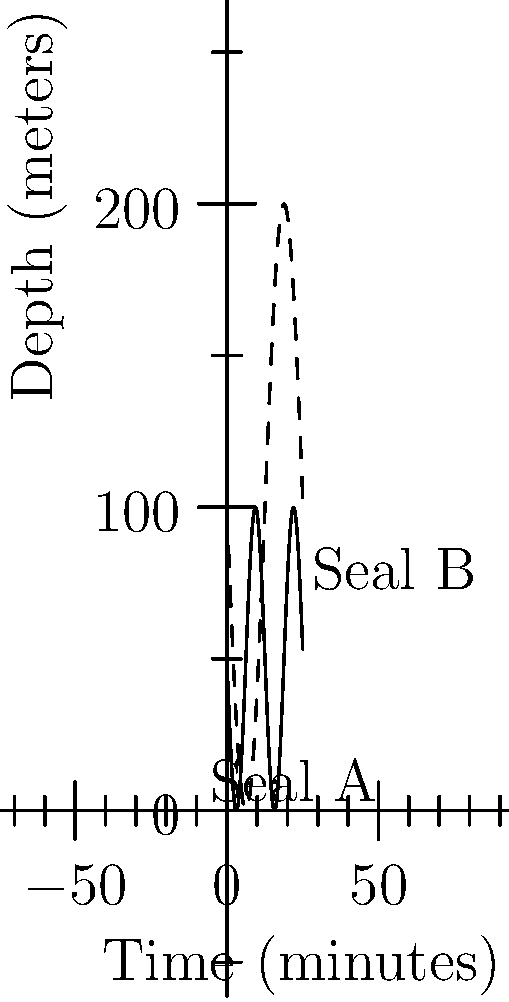The graph shows the diving patterns of two seals over a 25-minute period. Which seal spent more time at depths greater than 75 meters? To determine which seal spent more time at depths greater than 75 meters, we need to analyze the graph:

1. The solid line represents Seal A, and the dashed line represents Seal B.

2. The y-axis shows depth, with greater depths at lower positions on the graph.

3. We need to look at the portions of each line that are below the 75-meter mark:

   Seal A:
   - Never reaches depths greater than 75 meters.

   Seal B:
   - Reaches depths greater than 75 meters twice during the 25-minute period.
   - Each deep dive lasts approximately 6-7 minutes.

4. Calculating total time:
   Seal A: 0 minutes
   Seal B: Approximately 12-14 minutes

Therefore, Seal B spent more time at depths greater than 75 meters.
Answer: Seal B 